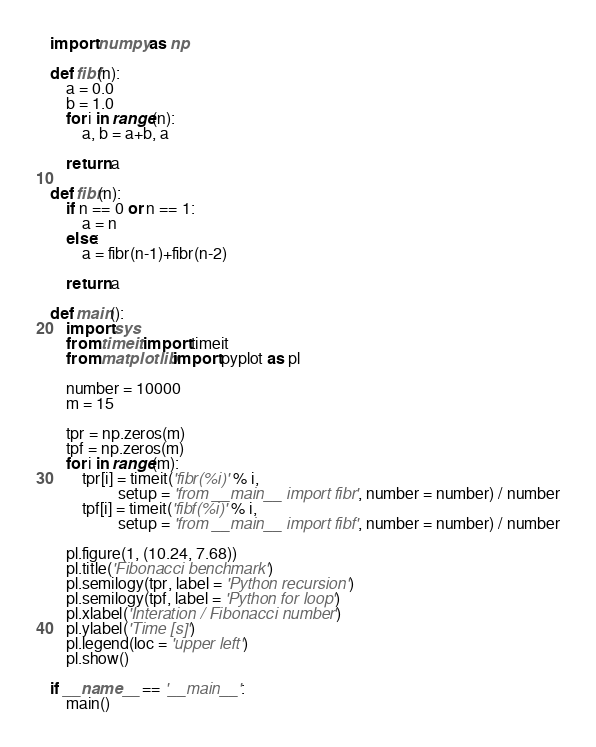<code> <loc_0><loc_0><loc_500><loc_500><_Python_>import numpy as np

def fibf(n):
    a = 0.0
    b = 1.0
    for i in range(n):
        a, b = a+b, a

    return a

def fibr(n):
    if n == 0 or n == 1:
        a = n
    else:
        a = fibr(n-1)+fibr(n-2)

    return a

def main():
    import sys
    from timeit import timeit
    from matplotlib import pyplot as pl

    number = 10000
    m = 15

    tpr = np.zeros(m)
    tpf = np.zeros(m)
    for i in range(m):
        tpr[i] = timeit('fibr(%i)' % i,
                 setup = 'from __main__ import fibr', number = number) / number
        tpf[i] = timeit('fibf(%i)' % i,
                 setup = 'from __main__ import fibf', number = number) / number

    pl.figure(1, (10.24, 7.68))
    pl.title('Fibonacci benchmark')
    pl.semilogy(tpr, label = 'Python recursion')
    pl.semilogy(tpf, label = 'Python for loop')
    pl.xlabel('Interation / Fibonacci number')
    pl.ylabel('Time [s]')
    pl.legend(loc = 'upper left')
    pl.show()

if __name__ == '__main__':
    main()

</code> 